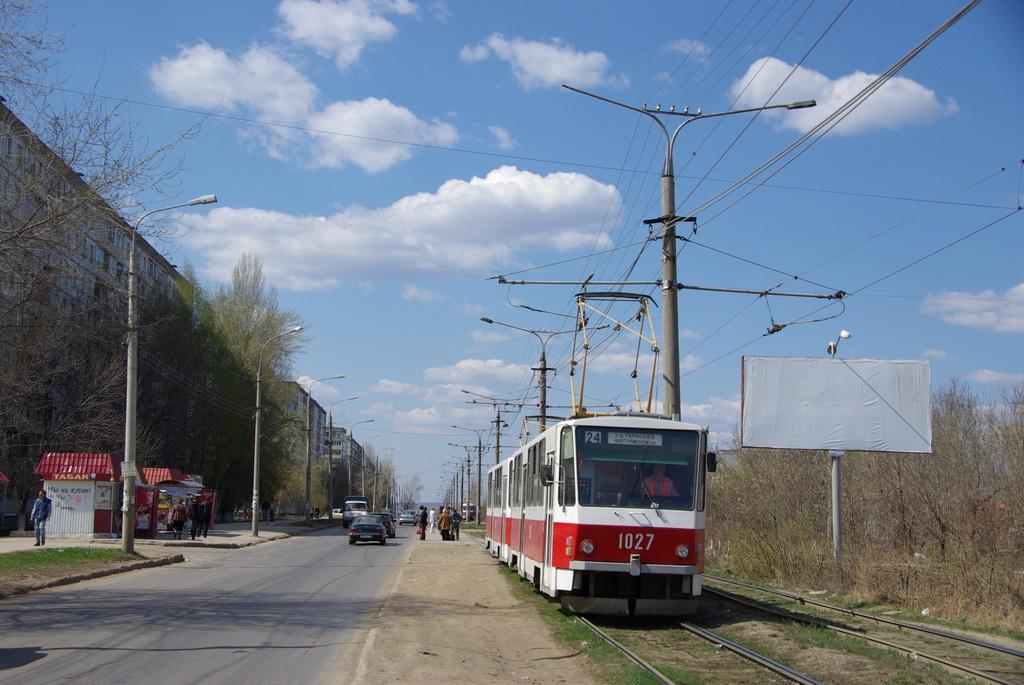Please provide a concise description of this image. In this image we can see a locomotive on the track. We can also see a person from a window, some grass, a group of trees, some people standing on the pathway, a board with a pole, wires, street poles, a group of buildings and the sky which looks cloudy. 